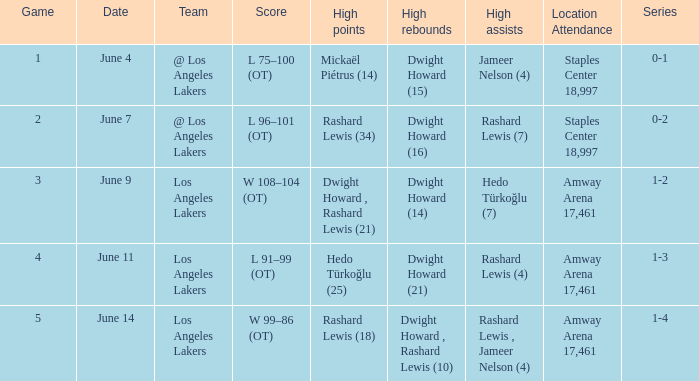Give me the full table as a dictionary. {'header': ['Game', 'Date', 'Team', 'Score', 'High points', 'High rebounds', 'High assists', 'Location Attendance', 'Series'], 'rows': [['1', 'June 4', '@ Los Angeles Lakers', 'L 75–100 (OT)', 'Mickaël Piétrus (14)', 'Dwight Howard (15)', 'Jameer Nelson (4)', 'Staples Center 18,997', '0-1'], ['2', 'June 7', '@ Los Angeles Lakers', 'L 96–101 (OT)', 'Rashard Lewis (34)', 'Dwight Howard (16)', 'Rashard Lewis (7)', 'Staples Center 18,997', '0-2'], ['3', 'June 9', 'Los Angeles Lakers', 'W 108–104 (OT)', 'Dwight Howard , Rashard Lewis (21)', 'Dwight Howard (14)', 'Hedo Türkoğlu (7)', 'Amway Arena 17,461', '1-2'], ['4', 'June 11', 'Los Angeles Lakers', 'L 91–99 (OT)', 'Hedo Türkoğlu (25)', 'Dwight Howard (21)', 'Rashard Lewis (4)', 'Amway Arena 17,461', '1-3'], ['5', 'June 14', 'Los Angeles Lakers', 'W 99–86 (OT)', 'Rashard Lewis (18)', 'Dwight Howard , Rashard Lewis (10)', 'Rashard Lewis , Jameer Nelson (4)', 'Amway Arena 17,461', '1-4']]} What is the series on "june 7"? 0-2. 